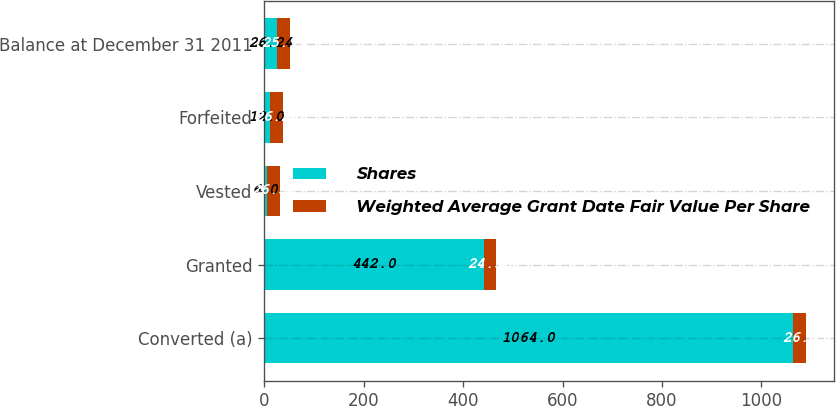Convert chart to OTSL. <chart><loc_0><loc_0><loc_500><loc_500><stacked_bar_chart><ecel><fcel>Converted (a)<fcel>Granted<fcel>Vested<fcel>Forfeited<fcel>Balance at December 31 2011<nl><fcel>Shares<fcel>1064<fcel>442<fcel>6<fcel>12<fcel>26.24<nl><fcel>Weighted Average Grant Date Fair Value Per Share<fcel>26.5<fcel>24.58<fcel>26.58<fcel>26.24<fcel>25.93<nl></chart> 